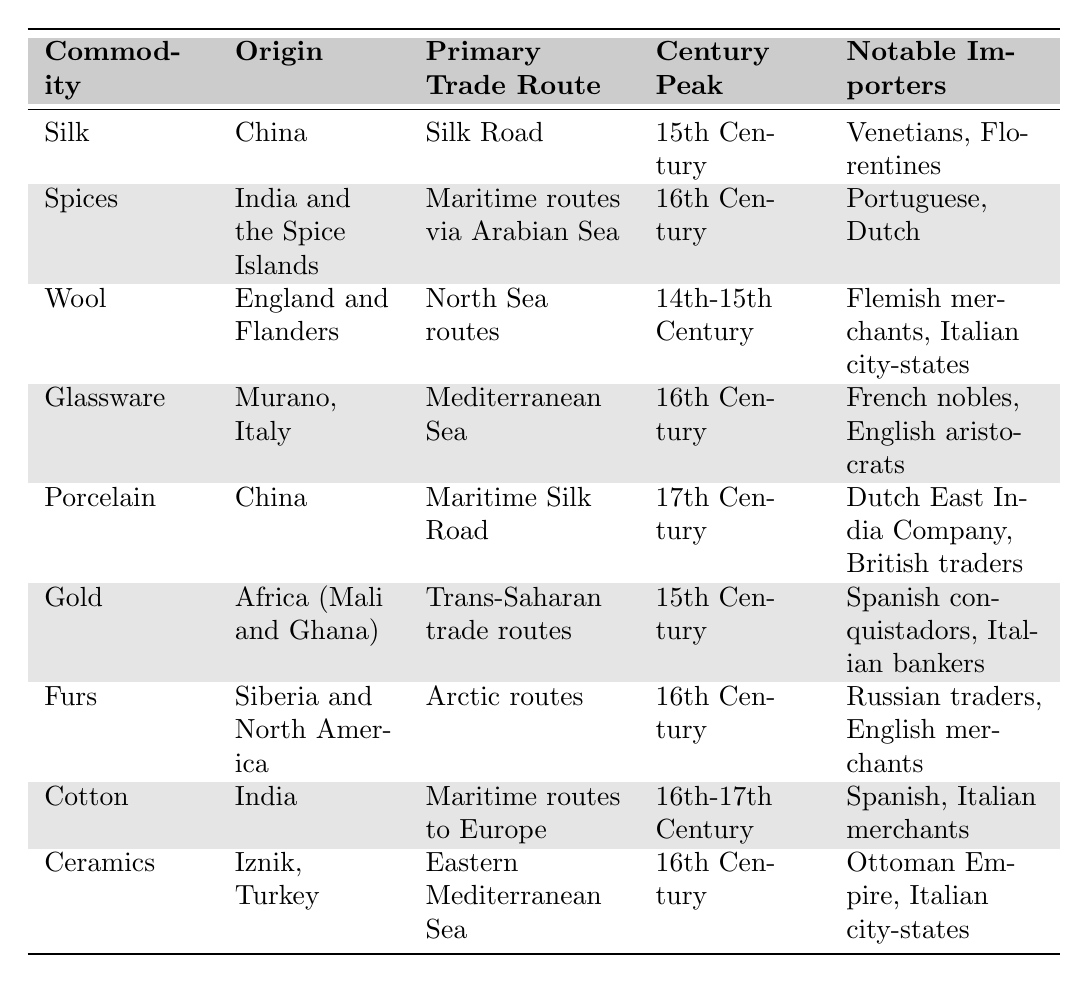What is the primary trade route for spices? The table indicates that the primary trade route for spices is the maritime routes via the Arabian Sea.
Answer: Maritime routes via Arabian Sea Which commodity had its peak in the 14th-15th century? The table shows that wool reached its peak during the 14th-15th century.
Answer: Wool How many notable importers are listed for glassware? The table lists two notable importers for glassware: French nobles and English aristocrats.
Answer: 2 Is porcelain imported by any notable importers from China? Yes, the table states that the Dutch East India Company and British traders are notable importers of porcelain from China.
Answer: Yes What is the origin of the commodity that had its peak in the 17th century? Porcelain is the commodity with a peak in the 17th century, and its origin is China according to the table.
Answer: China Which commodity had notable importers from both the Ottoman Empire and Italian city-states? The commodity ceramics, as seen in the table, had notable importers from both the Ottoman Empire and Italian city-states.
Answer: Ceramics Which two commodities are imported by merchants from India? The table shows that both spices and cotton have notable importers that include Spanish and Italian merchants, who sourced these from India.
Answer: Spices and Cotton What century did both silk and gold peak? According to the table, both silk and gold had their peak in the 15th century.
Answer: 15th Century How many commodities peaked in the 16th century? The table shows that a total of four commodities peaked in the 16th century: spices, glassware, furs, and ceramics. Thus, to find the answer, we count these entries.
Answer: 4 Which commodity has the largest geographical variety of notable importers listed? The commodity that has notable importers from both Europe and North America is furs, involving Russian traders and English merchants, representing a broader geographical variety.
Answer: Furs 